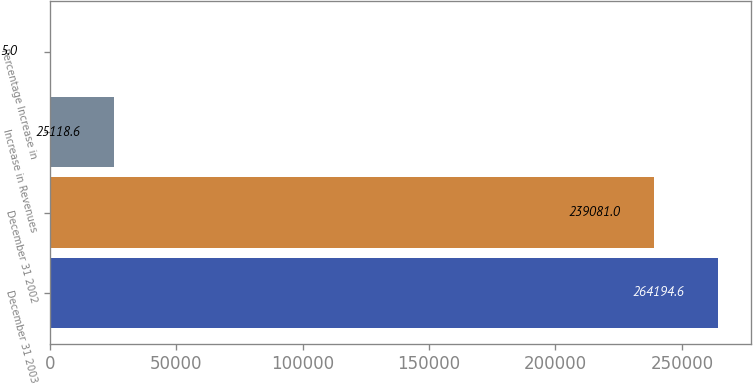Convert chart. <chart><loc_0><loc_0><loc_500><loc_500><bar_chart><fcel>December 31 2003<fcel>December 31 2002<fcel>Increase in Revenues<fcel>Percentage Increase in<nl><fcel>264195<fcel>239081<fcel>25118.6<fcel>5<nl></chart> 